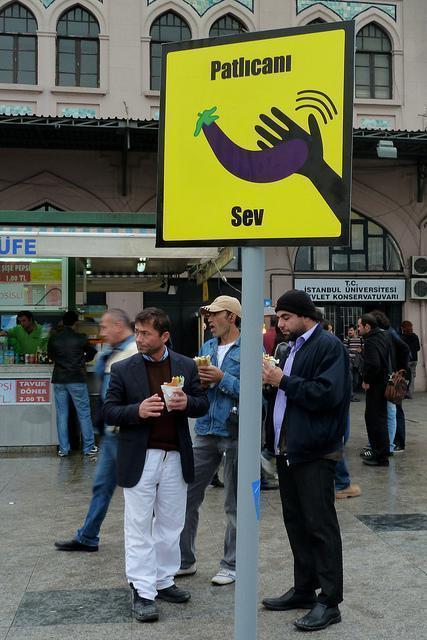What great empire once ruled this land?
From the following set of four choices, select the accurate answer to respond to the question.
Options: Indian, serbian, mayan, ottoman. Ottoman. 